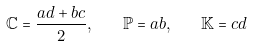Convert formula to latex. <formula><loc_0><loc_0><loc_500><loc_500>\mathbb { C } = \frac { a d + b c } { 2 } , \quad \mathbb { P } = a b , \quad \mathbb { K } = c d</formula> 